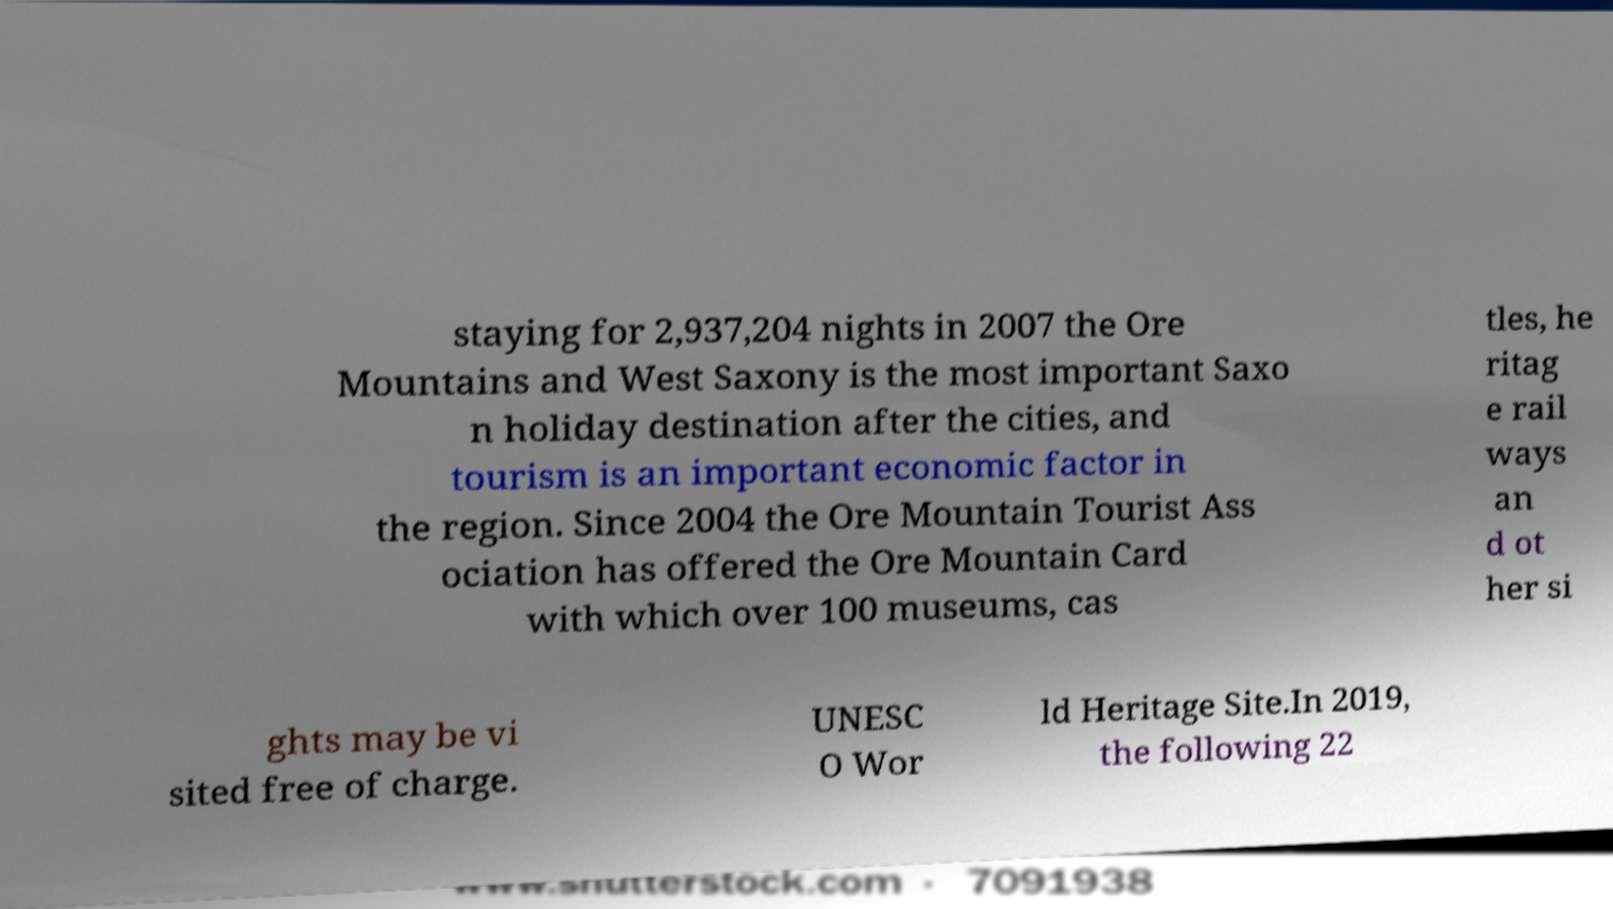Could you assist in decoding the text presented in this image and type it out clearly? staying for 2,937,204 nights in 2007 the Ore Mountains and West Saxony is the most important Saxo n holiday destination after the cities, and tourism is an important economic factor in the region. Since 2004 the Ore Mountain Tourist Ass ociation has offered the Ore Mountain Card with which over 100 museums, cas tles, he ritag e rail ways an d ot her si ghts may be vi sited free of charge. UNESC O Wor ld Heritage Site.In 2019, the following 22 